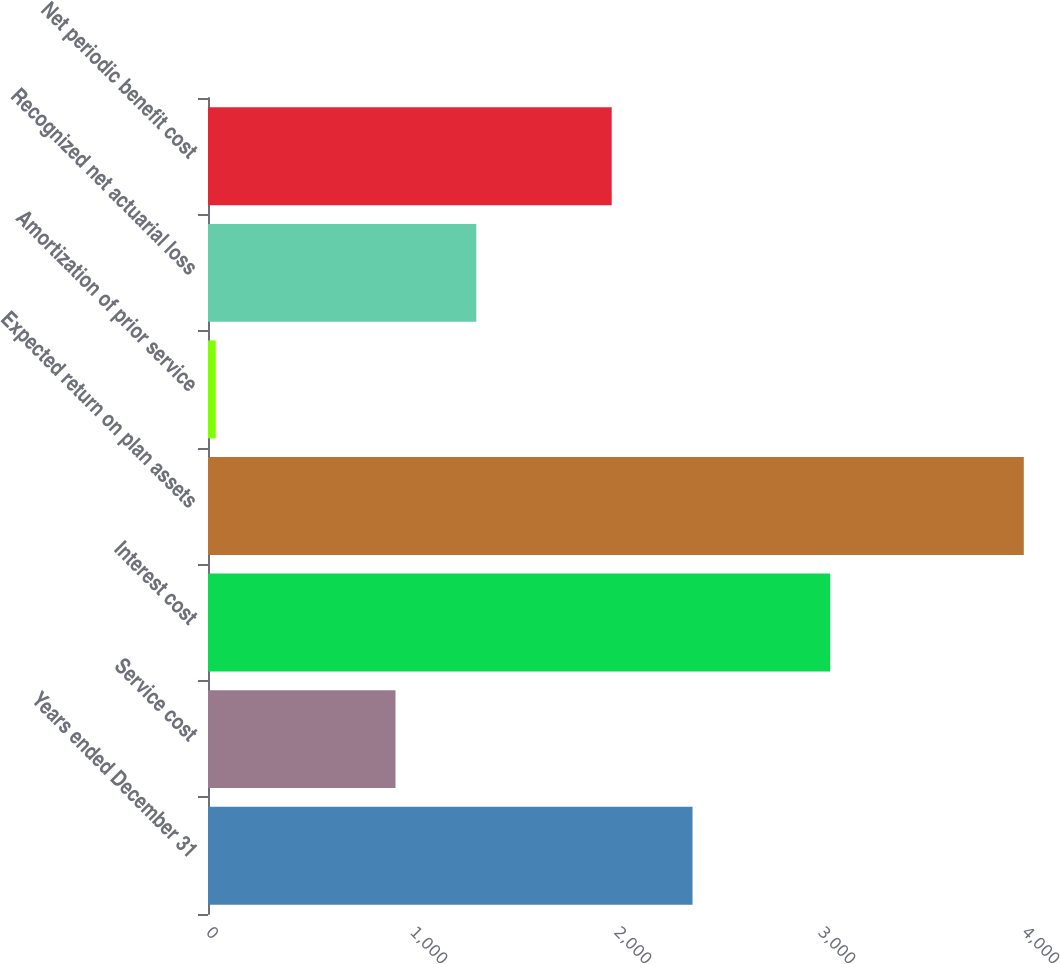<chart> <loc_0><loc_0><loc_500><loc_500><bar_chart><fcel>Years ended December 31<fcel>Service cost<fcel>Interest cost<fcel>Expected return on plan assets<fcel>Amortization of prior service<fcel>Recognized net actuarial loss<fcel>Net periodic benefit cost<nl><fcel>2375.1<fcel>919.1<fcel>3050<fcel>3999<fcel>38<fcel>1315.2<fcel>1979<nl></chart> 